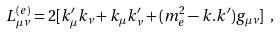Convert formula to latex. <formula><loc_0><loc_0><loc_500><loc_500>L ^ { ( e ) } _ { \mu \nu } = 2 [ k ^ { \prime } _ { \mu } k _ { \nu } + k _ { \mu } k ^ { \prime } _ { \nu } + ( m ^ { 2 } _ { e } - k . k ^ { \prime } ) g _ { \mu \nu } ] \ ,</formula> 